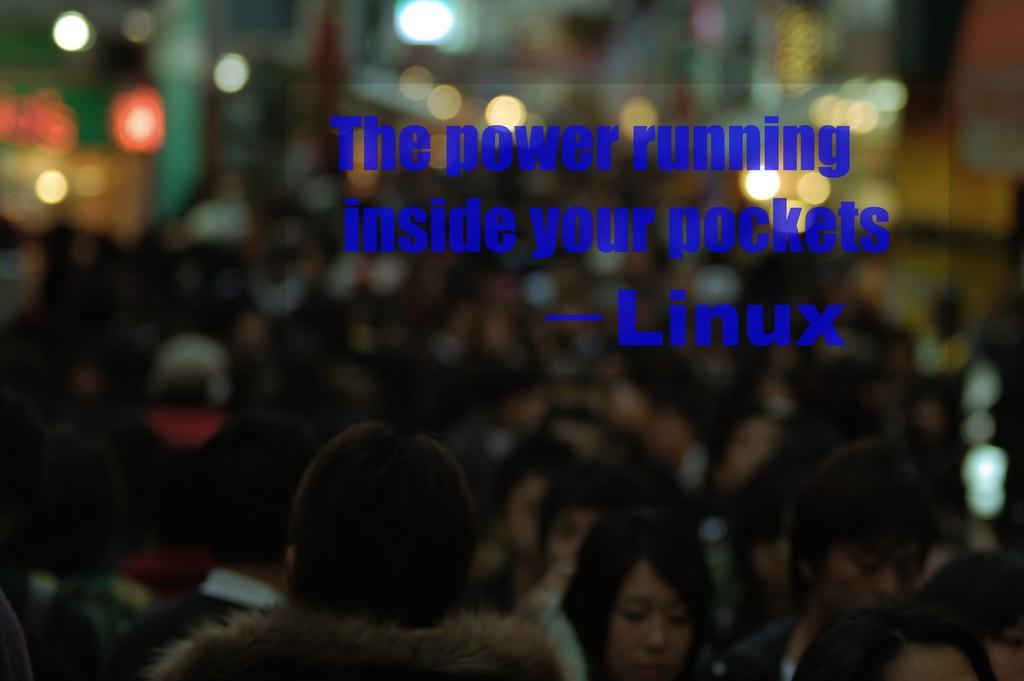Could you give a brief overview of what you see in this image? In this image I can see group of people. In the background I can see few lights and I can see something written on the image. 